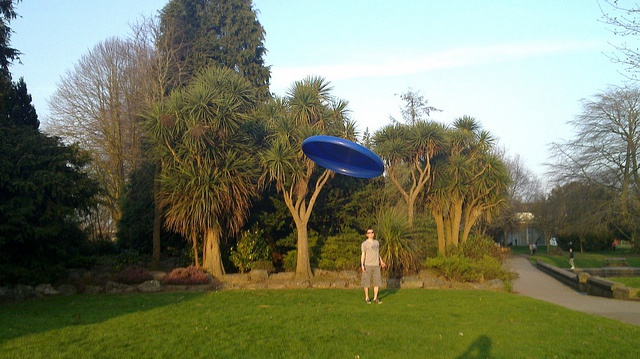Describe the objects in this image and their specific colors. I can see frisbee in purple, navy, blue, gray, and darkblue tones, people in purple and tan tones, people in purple, black, gray, and darkgreen tones, people in purple, darkgreen, black, and gray tones, and people in purple, black, maroon, and brown tones in this image. 